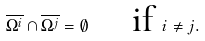<formula> <loc_0><loc_0><loc_500><loc_500>\overline { \Omega ^ { i } } \cap \overline { \Omega ^ { j } } = \emptyset \quad \text { if } i \neq j .</formula> 